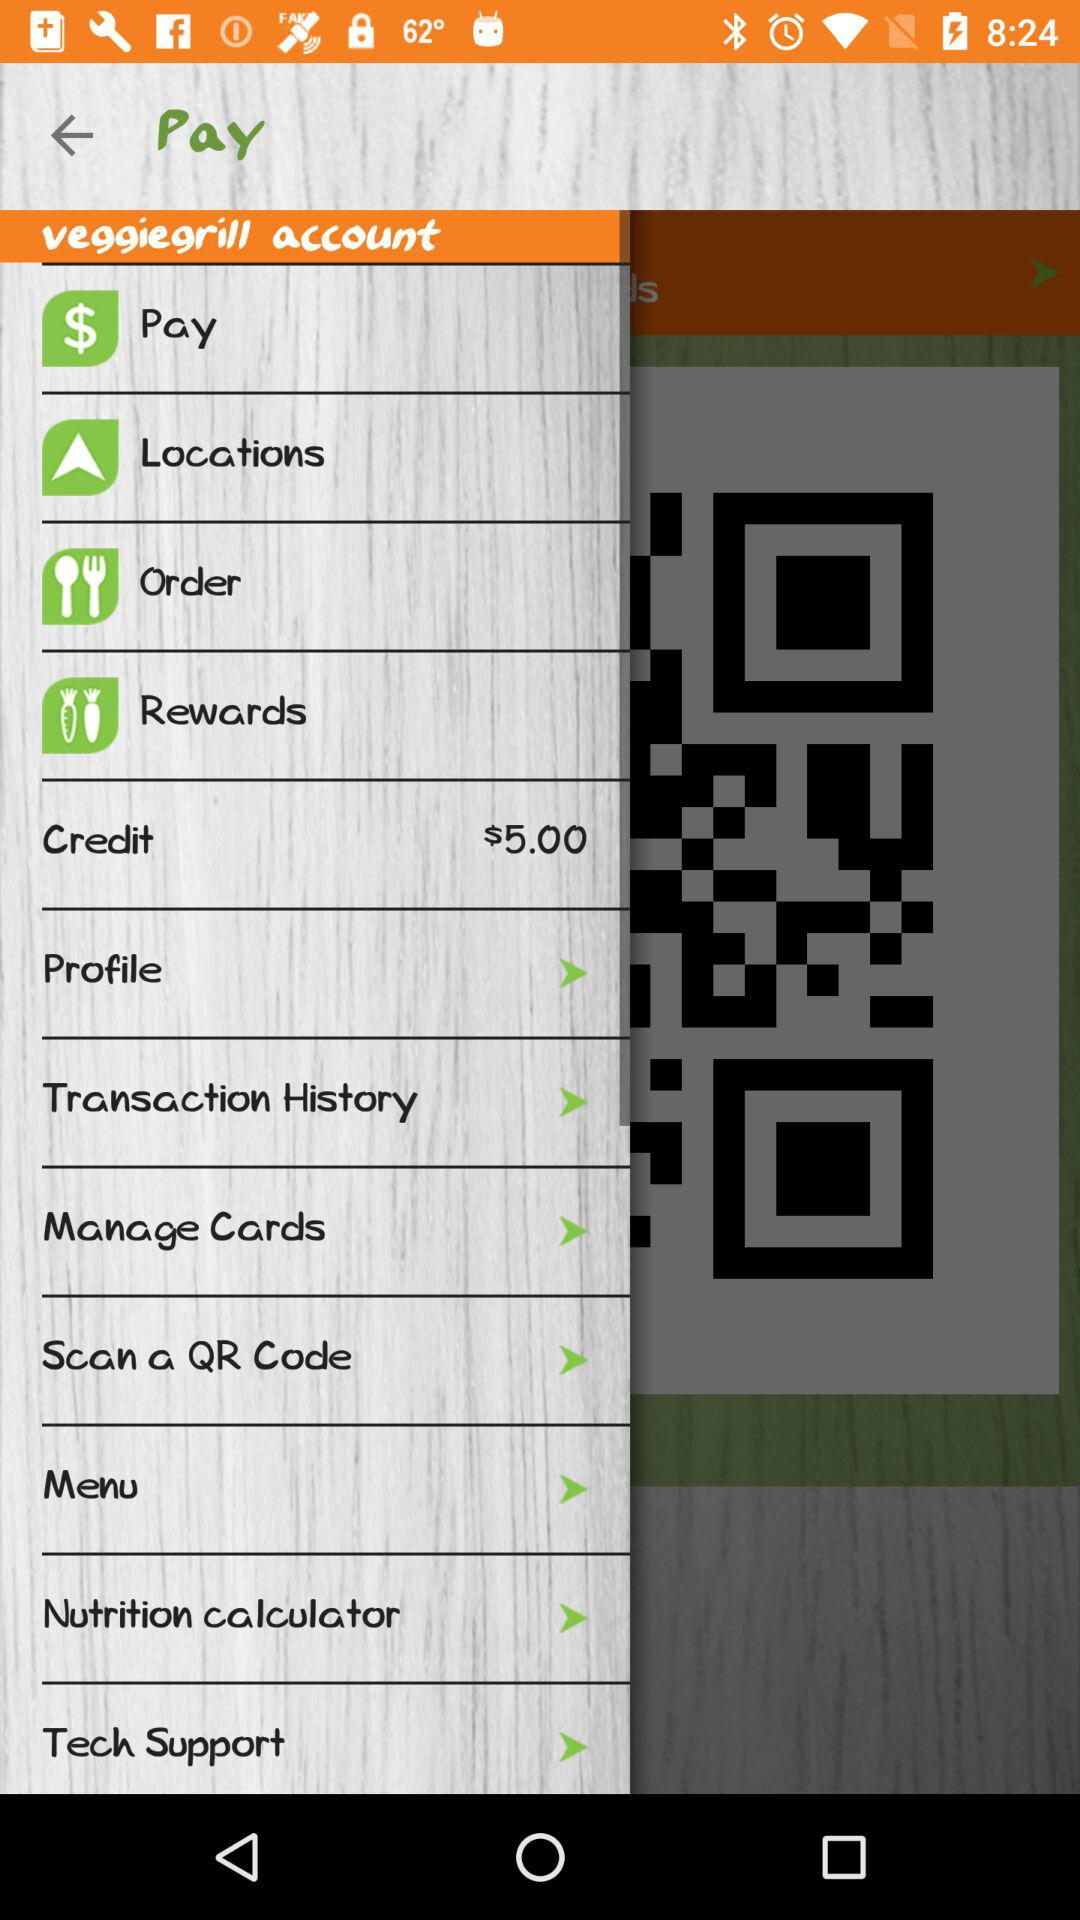What is the available balance in "Credit"? The available balance in "Credit" is $5.00. 